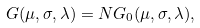Convert formula to latex. <formula><loc_0><loc_0><loc_500><loc_500>G ( \mu , \sigma , \lambda ) = N G _ { 0 } ( \mu , \sigma , \lambda ) ,</formula> 